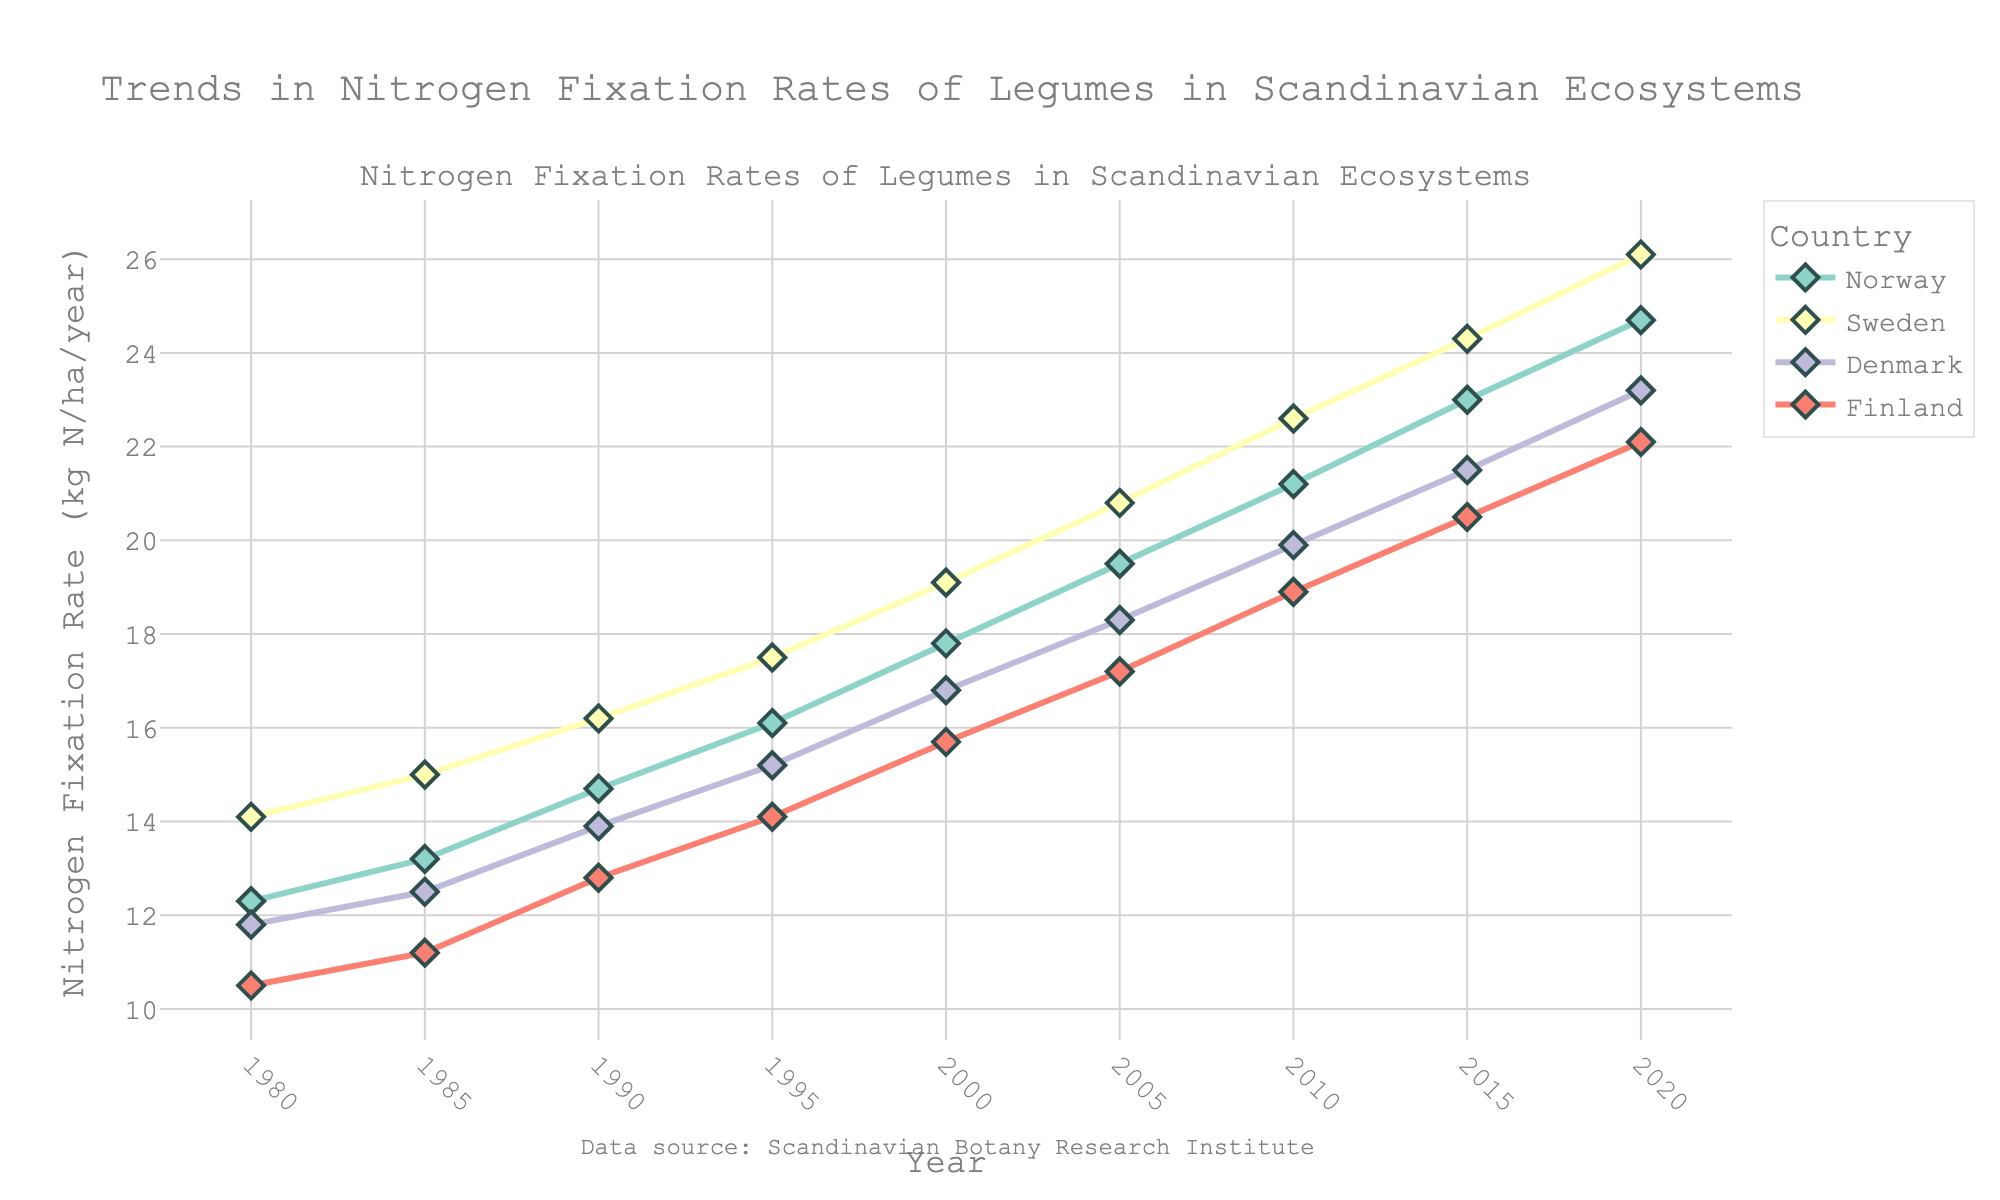What country showed the largest increase in nitrogen fixation rates from 1980 to 2020? Identify the nitrogen fixation rates for each country in 1980 and 2020. Calculate the difference for each country: Norway (24.7 - 12.3 = 12.4), Sweden (26.1 - 14.1 = 12.0), Denmark (23.2 - 11.8 = 11.4), Finland (22.1 - 10.5 = 11.6). The largest increase is for Norway.
Answer: Norway By what amount did Finland's nitrogen fixation rate increase between 1990 and 2010? Identify the nitrogen fixation rates for Finland in 1990 and 2010. Calculate the difference: 18.9 - 12.8 = 6.1.
Answer: 6.1 Which country had the highest nitrogen fixation rate in 2005? Check the nitrogen fixation rates for all countries in 2005. Sweden's value of 20.8 is the highest.
Answer: Sweden In what year did Denmark's nitrogen fixation rate surpass 20 kg N/ha/year? Look through Denmark's data. Denmark surpasses 20 kg N/ha/year by 2015 with a value of 21.5.
Answer: 2015 How does the nitrogen fixation rate in Norway compare to that in Sweden in 2020? Assess the nitrogen fixation rates for Norway (24.7) and Sweden (26.1) in 2020. Sweden's rate is higher.
Answer: Sweden is higher Calculate the average nitrogen fixation rate in 2000 across all four countries. Identify the nitrogen fixation rates for 2000: Norway (17.8), Sweden (19.1), Denmark (16.8), Finland (15.7). Calculate the average: (17.8 + 19.1 + 16.8 + 15.7) / 4 = 17.35.
Answer: 17.35 Which country has the smallest change in nitrogen fixation rate between any two consecutive recorded years? For each country, calculate the changes between consecutive years and find the smallest change: Norway (1.1), Sweden (0.9), Denmark (0.7), Finland (0.7). The smallest change is for Denmark between 1980 and 1985, and Finland between 1980 and 1985 both with 0.7.
Answer: Denmark, Finland (0.7) Did all countries exhibit a steady increase in nitrogen fixation rates over the years, or were there any decreases observed? Examine the trends for each country. All show consistent increases; no decreases can be observed.
Answer: Steady increase for all What is the total nitrogen fixation rate sum for all countries in the year 1995? Identify the nitrogen fixation rates for 1995: Norway (16.1), Sweden (17.5), Denmark (15.2), Finland (14.1). Calculate the total: 16.1 + 17.5 + 15.2 + 14.1 = 62.9.
Answer: 62.9 